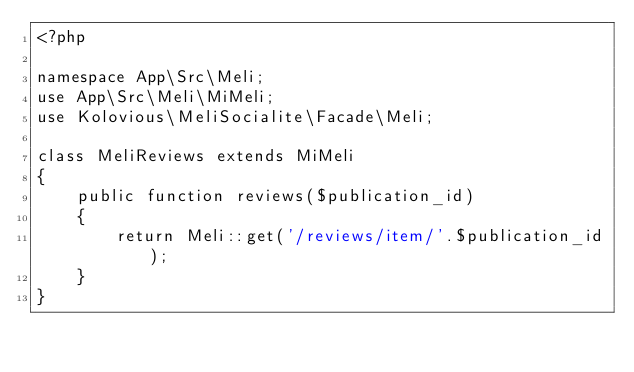<code> <loc_0><loc_0><loc_500><loc_500><_PHP_><?php

namespace App\Src\Meli;
use App\Src\Meli\MiMeli;
use Kolovious\MeliSocialite\Facade\Meli;

class MeliReviews extends MiMeli
{
    public function reviews($publication_id)
    {
        return Meli::get('/reviews/item/'.$publication_id);
    }
}
</code> 